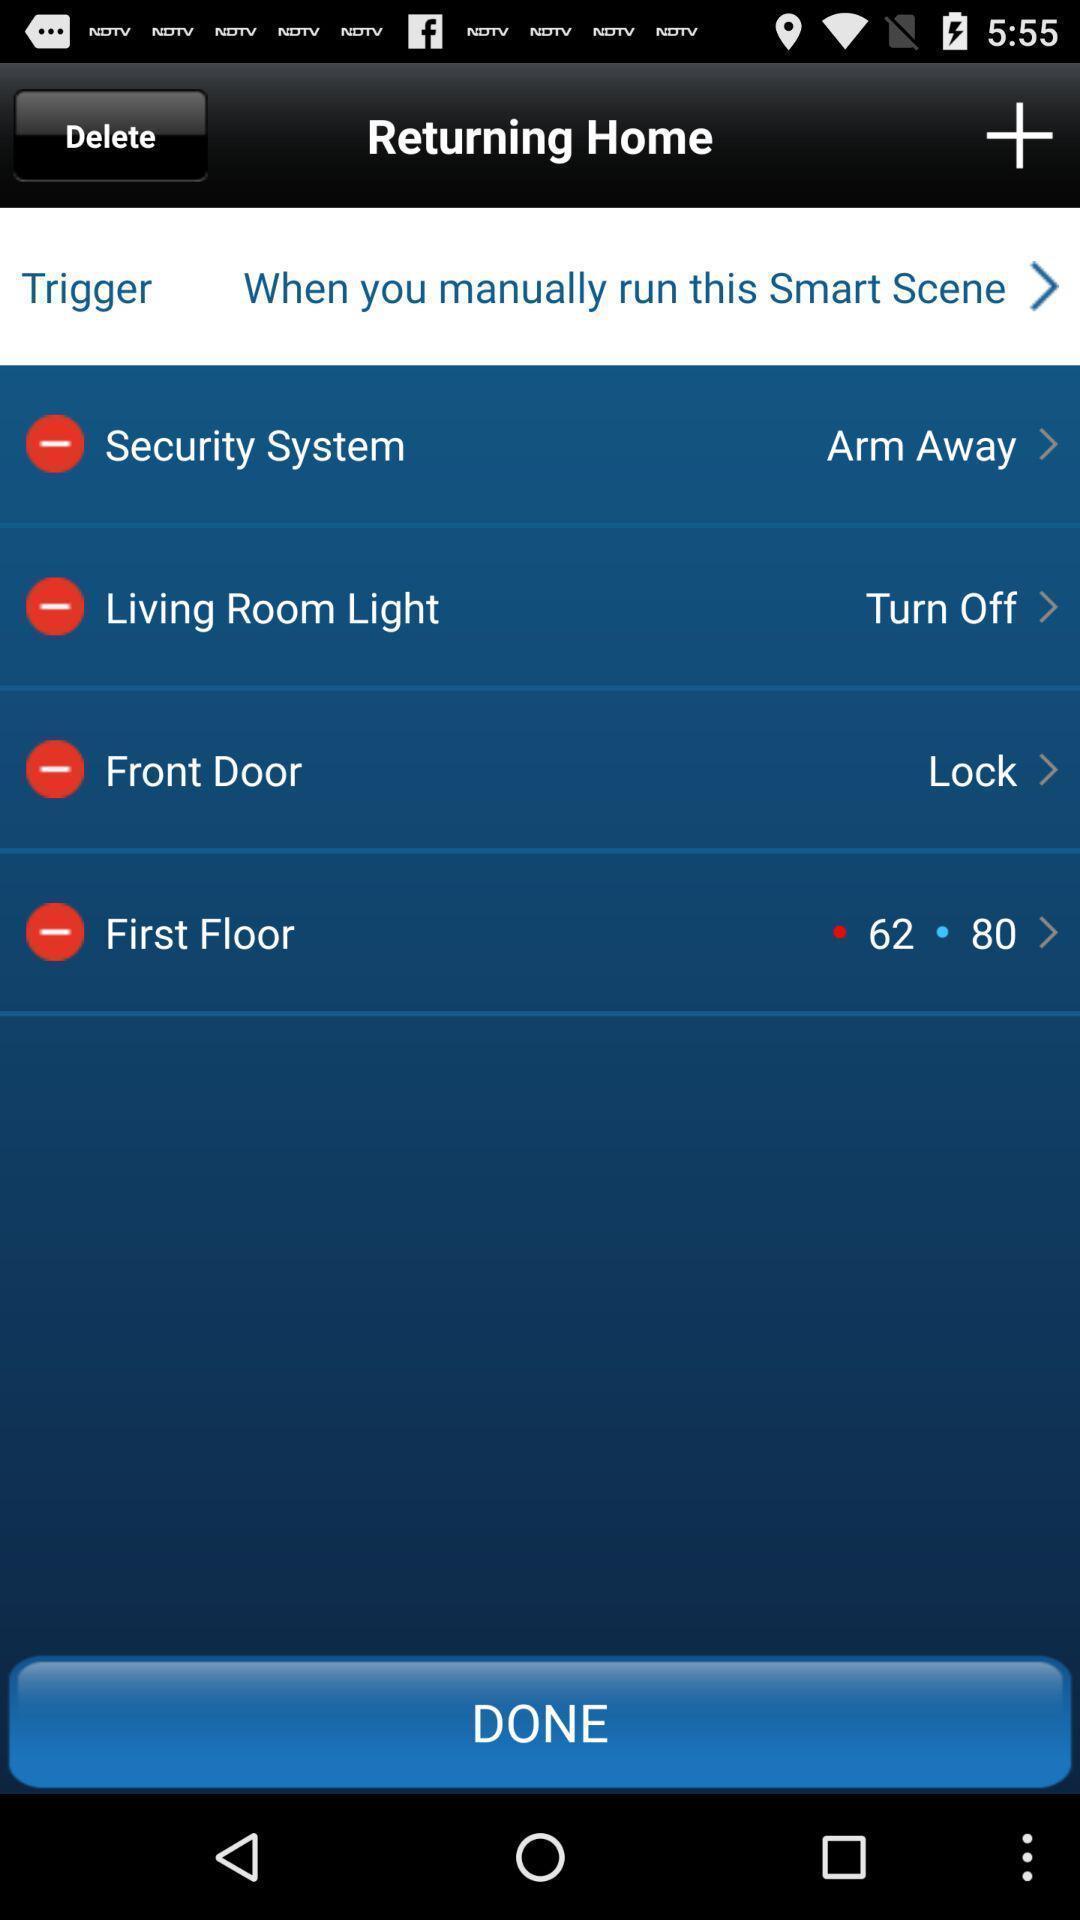Explain what's happening in this screen capture. Screen showing returning home with options. 